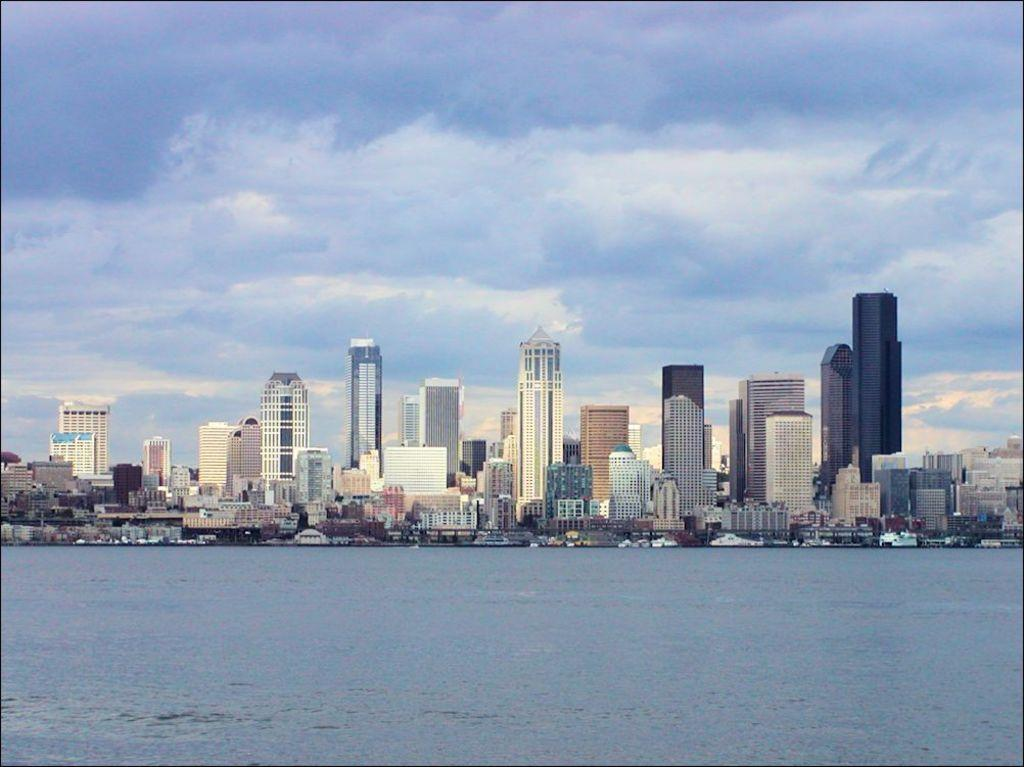What is at the bottom of the image? There is water at the bottom of the image. What can be seen behind the water? There are buildings behind the water. What is visible at the top of the image? The sky is visible at the top of the image. What can be observed in the sky? Clouds are present in the sky. Where is the beginner park located in the image? There is no mention of a beginner park in the image, so it cannot be located. What type of ball is being used in the image? There is no ball present in the image. 